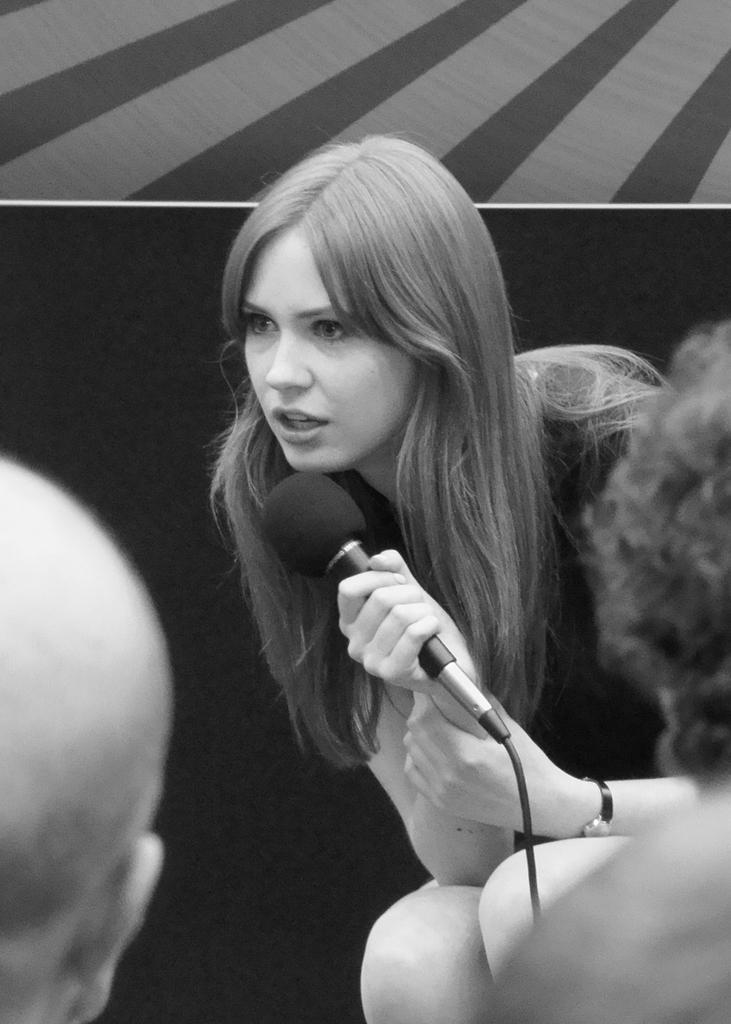Please provide a concise description of this image. In this image I see a woman, who is holding a mic. I can also see 2 persons head. 